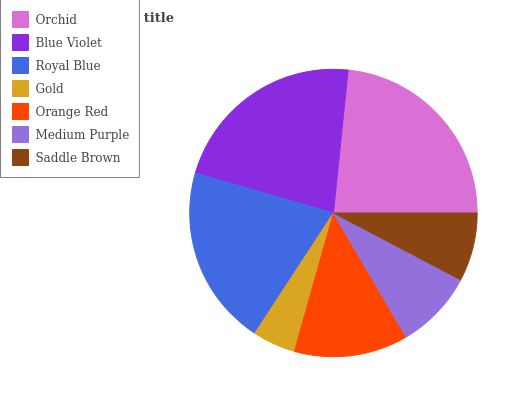Is Gold the minimum?
Answer yes or no. Yes. Is Orchid the maximum?
Answer yes or no. Yes. Is Blue Violet the minimum?
Answer yes or no. No. Is Blue Violet the maximum?
Answer yes or no. No. Is Orchid greater than Blue Violet?
Answer yes or no. Yes. Is Blue Violet less than Orchid?
Answer yes or no. Yes. Is Blue Violet greater than Orchid?
Answer yes or no. No. Is Orchid less than Blue Violet?
Answer yes or no. No. Is Orange Red the high median?
Answer yes or no. Yes. Is Orange Red the low median?
Answer yes or no. Yes. Is Gold the high median?
Answer yes or no. No. Is Orchid the low median?
Answer yes or no. No. 